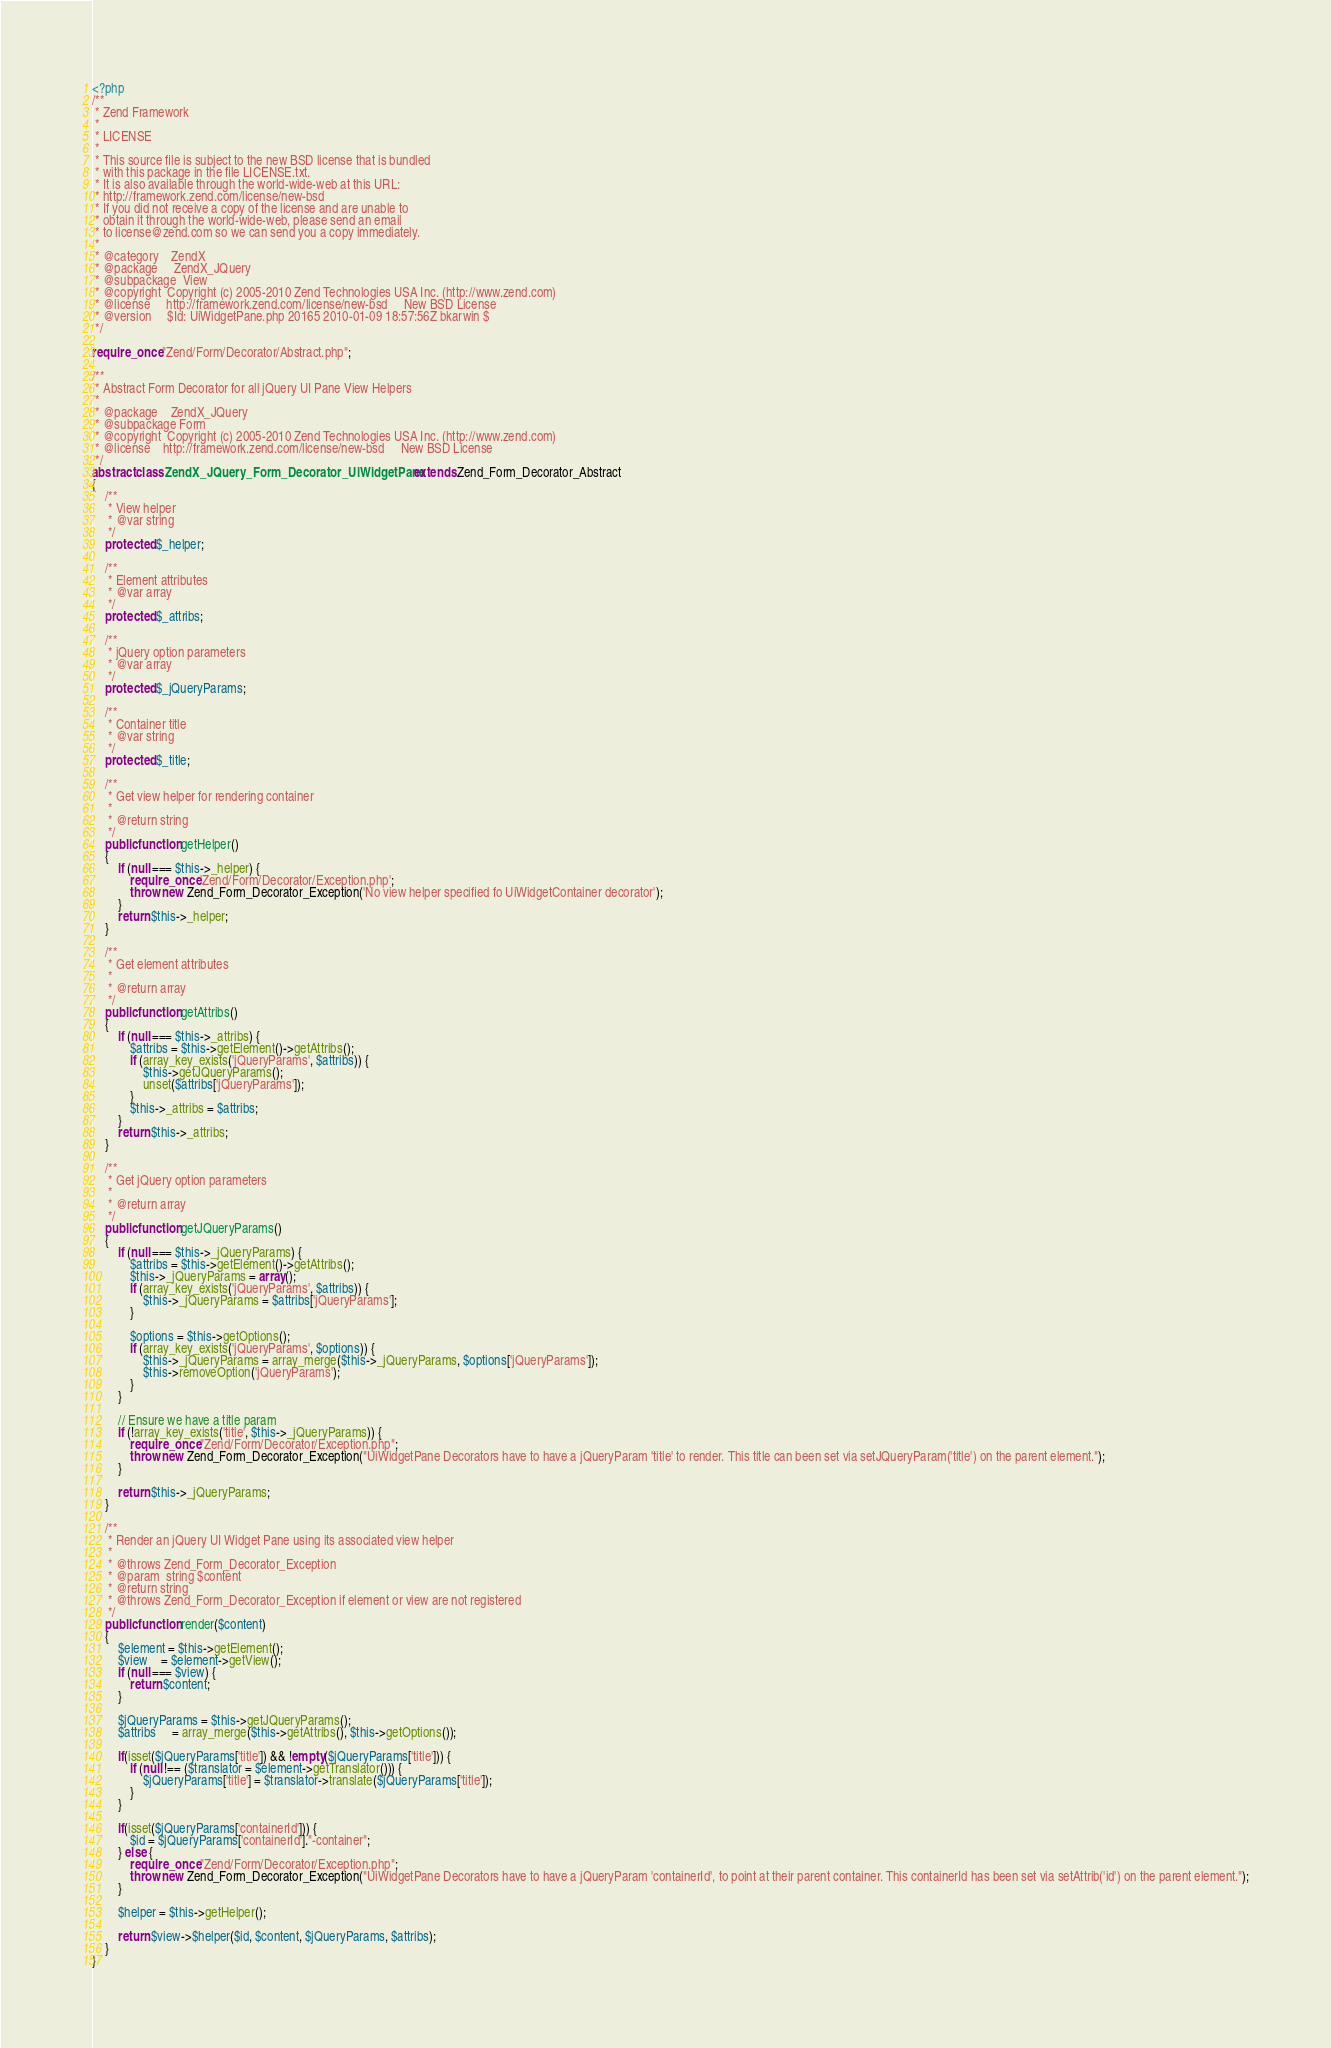<code> <loc_0><loc_0><loc_500><loc_500><_PHP_><?php
/**
 * Zend Framework
 *
 * LICENSE
 *
 * This source file is subject to the new BSD license that is bundled
 * with this package in the file LICENSE.txt.
 * It is also available through the world-wide-web at this URL:
 * http://framework.zend.com/license/new-bsd
 * If you did not receive a copy of the license and are unable to
 * obtain it through the world-wide-web, please send an email
 * to license@zend.com so we can send you a copy immediately.
 *
 * @category    ZendX
 * @package     ZendX_JQuery
 * @subpackage  View
 * @copyright  Copyright (c) 2005-2010 Zend Technologies USA Inc. (http://www.zend.com)
 * @license     http://framework.zend.com/license/new-bsd     New BSD License
 * @version     $Id: UiWidgetPane.php 20165 2010-01-09 18:57:56Z bkarwin $
 */

require_once "Zend/Form/Decorator/Abstract.php";

/**
 * Abstract Form Decorator for all jQuery UI Pane View Helpers
 *
 * @package    ZendX_JQuery
 * @subpackage Form
 * @copyright  Copyright (c) 2005-2010 Zend Technologies USA Inc. (http://www.zend.com)
 * @license    http://framework.zend.com/license/new-bsd     New BSD License
 */
abstract class ZendX_JQuery_Form_Decorator_UiWidgetPane extends Zend_Form_Decorator_Abstract
{
    /**
     * View helper
     * @var string
     */
    protected $_helper;

    /**
     * Element attributes
     * @var array
     */
    protected $_attribs;

    /**
     * jQuery option parameters
     * @var array
     */
    protected $_jQueryParams;

    /**
     * Container title
     * @var string
     */
    protected $_title;

    /**
     * Get view helper for rendering container
     *
     * @return string
     */
    public function getHelper()
    {
        if (null === $this->_helper) {
            require_once 'Zend/Form/Decorator/Exception.php';
            throw new Zend_Form_Decorator_Exception('No view helper specified fo UiWidgetContainer decorator');
        }
        return $this->_helper;
    }

    /**
     * Get element attributes
     *
     * @return array
     */
    public function getAttribs()
    {
        if (null === $this->_attribs) {
            $attribs = $this->getElement()->getAttribs();
            if (array_key_exists('jQueryParams', $attribs)) {
                $this->getJQueryParams();
                unset($attribs['jQueryParams']);
            }
            $this->_attribs = $attribs;
        }
        return $this->_attribs;
    }

    /**
     * Get jQuery option parameters
     *
     * @return array
     */
    public function getJQueryParams()
    {
        if (null === $this->_jQueryParams) {
            $attribs = $this->getElement()->getAttribs();
            $this->_jQueryParams = array();
            if (array_key_exists('jQueryParams', $attribs)) {
                $this->_jQueryParams = $attribs['jQueryParams'];
            }

            $options = $this->getOptions();
            if (array_key_exists('jQueryParams', $options)) {
                $this->_jQueryParams = array_merge($this->_jQueryParams, $options['jQueryParams']);
                $this->removeOption('jQueryParams');
            }
        }

        // Ensure we have a title param
        if (!array_key_exists('title', $this->_jQueryParams)) {
            require_once "Zend/Form/Decorator/Exception.php";
            throw new Zend_Form_Decorator_Exception("UiWidgetPane Decorators have to have a jQueryParam 'title' to render. This title can been set via setJQueryParam('title') on the parent element.");
        }

        return $this->_jQueryParams;
    }

    /**
     * Render an jQuery UI Widget Pane using its associated view helper
     *
     * @throws Zend_Form_Decorator_Exception
     * @param  string $content
     * @return string
     * @throws Zend_Form_Decorator_Exception if element or view are not registered
     */
    public function render($content)
    {
        $element = $this->getElement();
        $view    = $element->getView();
        if (null === $view) {
            return $content;
        }

        $jQueryParams = $this->getJQueryParams();
        $attribs     = array_merge($this->getAttribs(), $this->getOptions());

        if(isset($jQueryParams['title']) && !empty($jQueryParams['title'])) {
            if (null !== ($translator = $element->getTranslator())) {
                $jQueryParams['title'] = $translator->translate($jQueryParams['title']);
            }
        }

        if(isset($jQueryParams['containerId'])) {
            $id = $jQueryParams['containerId']."-container";
        } else {
            require_once "Zend/Form/Decorator/Exception.php";
            throw new Zend_Form_Decorator_Exception("UiWidgetPane Decorators have to have a jQueryParam 'containerId', to point at their parent container. This containerId has been set via setAttrib('id') on the parent element.");
        }

        $helper = $this->getHelper();

        return $view->$helper($id, $content, $jQueryParams, $attribs);
    }
}</code> 